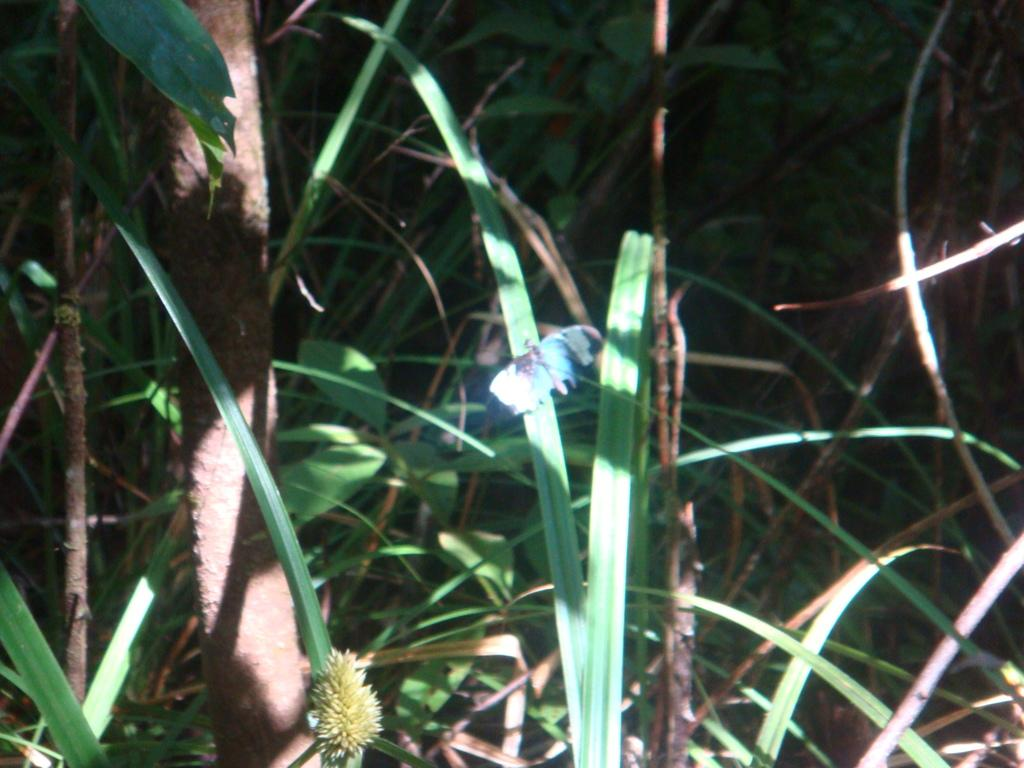What type of living organisms can be seen in the image? Plants can be seen in the image. What type of alley can be seen in the image? There is no alley present in the image; it features plants. Are there any pets visible in the image? There is no mention of pets in the image, only plants. 